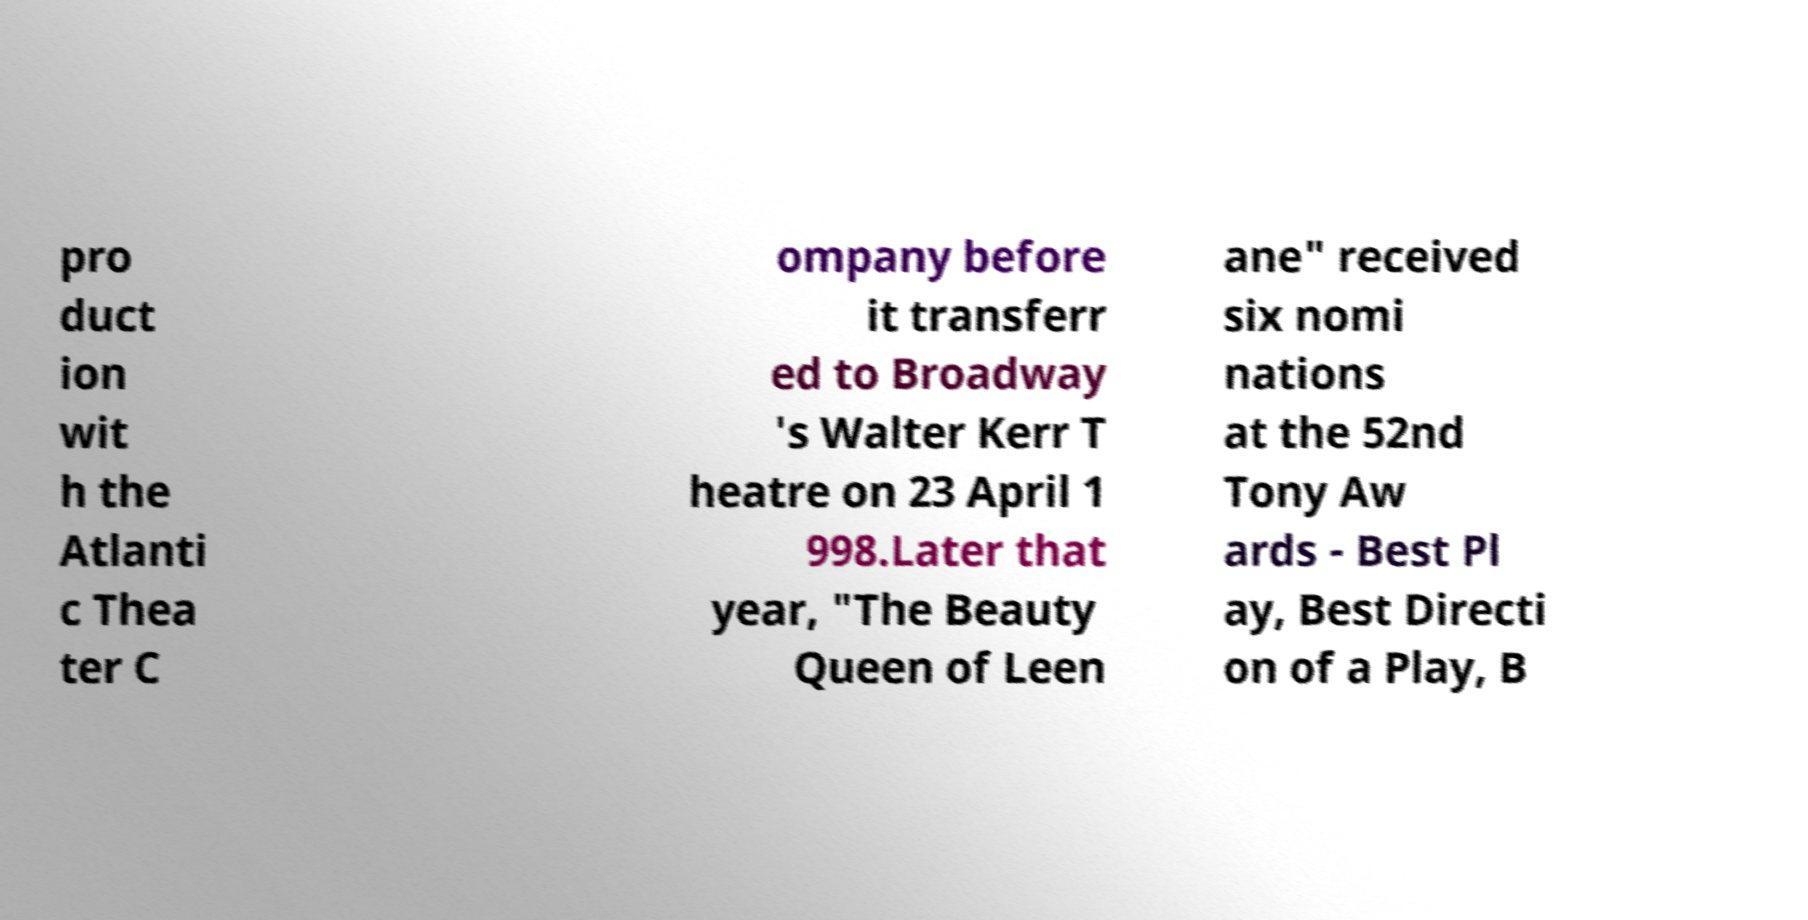Please read and relay the text visible in this image. What does it say? pro duct ion wit h the Atlanti c Thea ter C ompany before it transferr ed to Broadway 's Walter Kerr T heatre on 23 April 1 998.Later that year, "The Beauty Queen of Leen ane" received six nomi nations at the 52nd Tony Aw ards - Best Pl ay, Best Directi on of a Play, B 